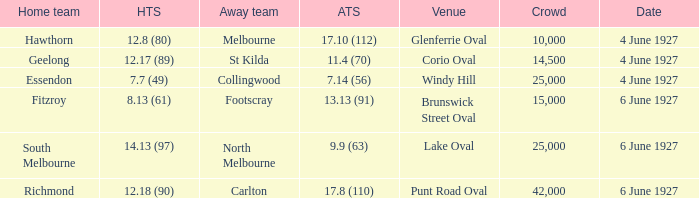Which venue's home team is geelong? Corio Oval. 